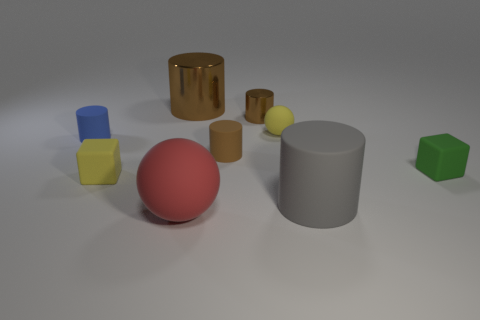Subtract 3 cylinders. How many cylinders are left? 2 Subtract all rubber cylinders. How many cylinders are left? 2 Subtract all cyan balls. How many brown cylinders are left? 3 Subtract all gray cylinders. How many cylinders are left? 4 Subtract all cyan cylinders. Subtract all gray blocks. How many cylinders are left? 5 Add 1 rubber things. How many objects exist? 10 Subtract all spheres. How many objects are left? 7 Subtract 0 green cylinders. How many objects are left? 9 Subtract all green things. Subtract all green rubber things. How many objects are left? 7 Add 4 large rubber cylinders. How many large rubber cylinders are left? 5 